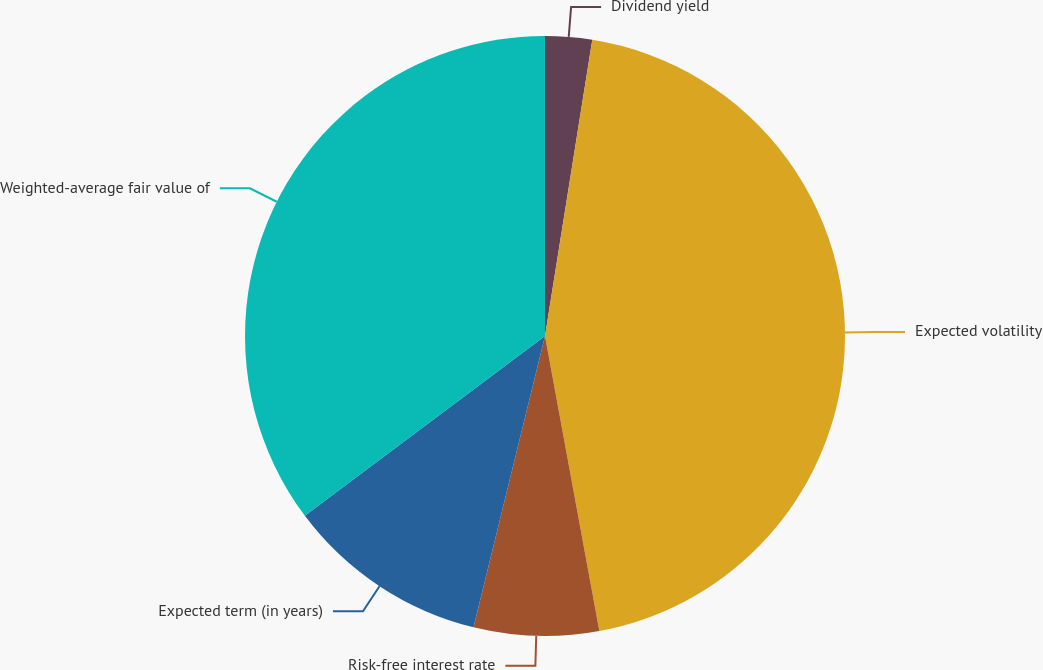Convert chart. <chart><loc_0><loc_0><loc_500><loc_500><pie_chart><fcel>Dividend yield<fcel>Expected volatility<fcel>Risk-free interest rate<fcel>Expected term (in years)<fcel>Weighted-average fair value of<nl><fcel>2.52%<fcel>44.58%<fcel>6.73%<fcel>10.94%<fcel>35.23%<nl></chart> 